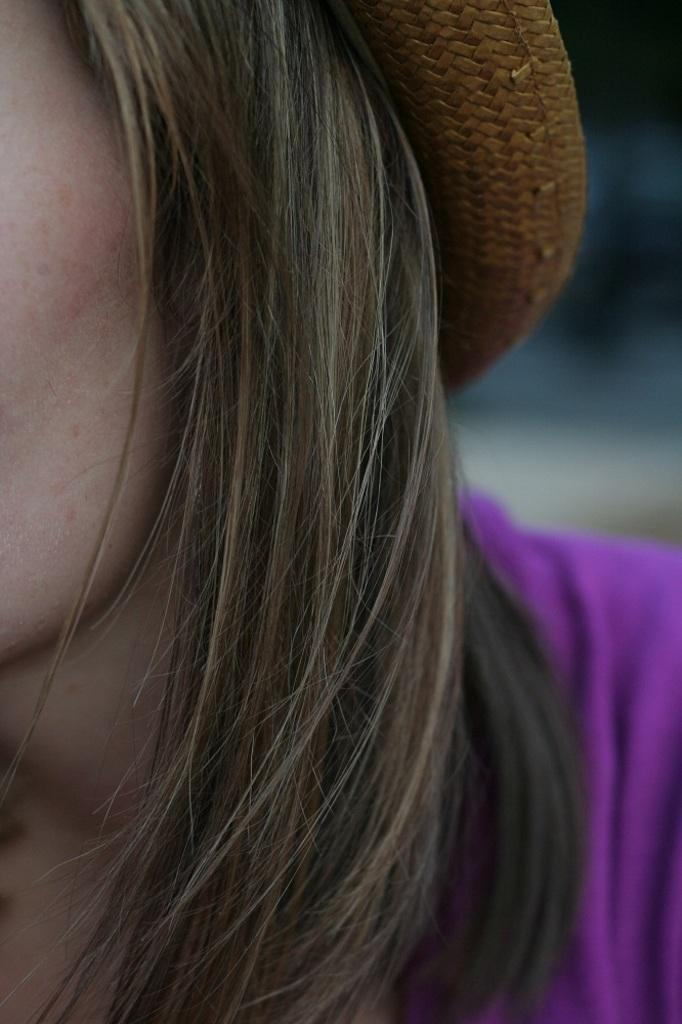Who is present in the image? There is a woman in the image. What is the woman wearing on her head? The woman is wearing a hat. What color is the dress the woman is wearing? The woman is wearing a blue color dress. Can you describe the background of the image? The background of the image is blurred. Where is the kitten playing on the floor in the image? There is no kitten or floor present in the image; it features a woman wearing a hat and a blue dress with a blurred background. 